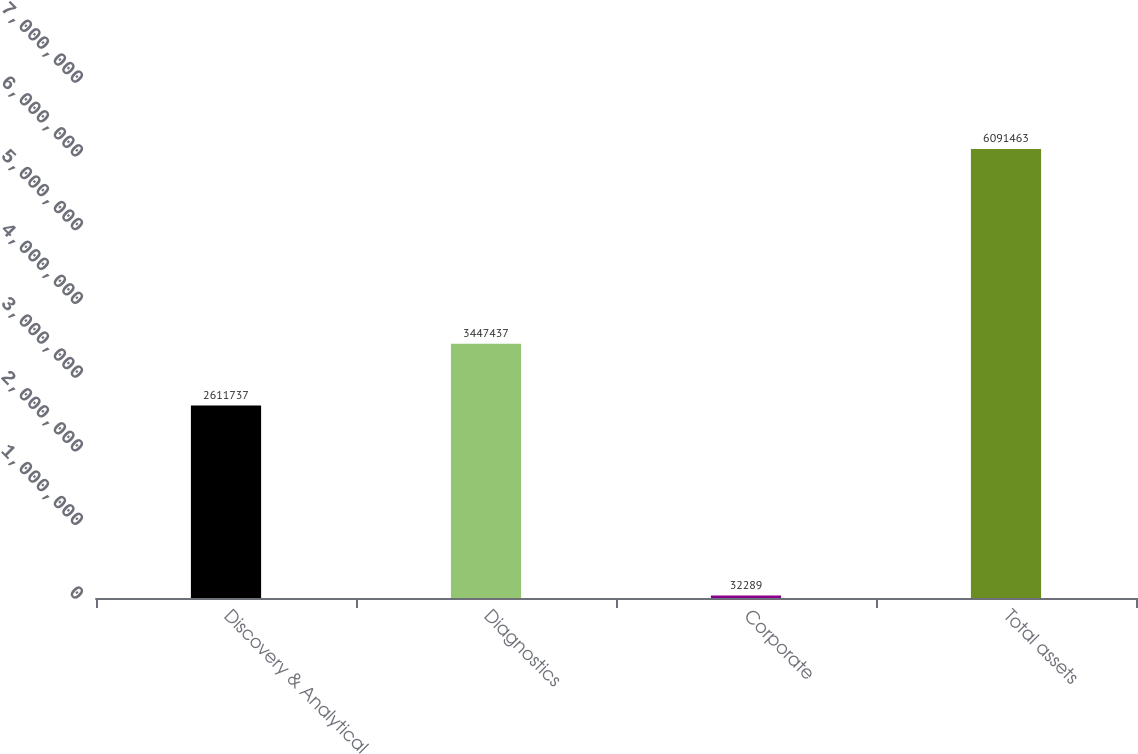<chart> <loc_0><loc_0><loc_500><loc_500><bar_chart><fcel>Discovery & Analytical<fcel>Diagnostics<fcel>Corporate<fcel>Total assets<nl><fcel>2.61174e+06<fcel>3.44744e+06<fcel>32289<fcel>6.09146e+06<nl></chart> 